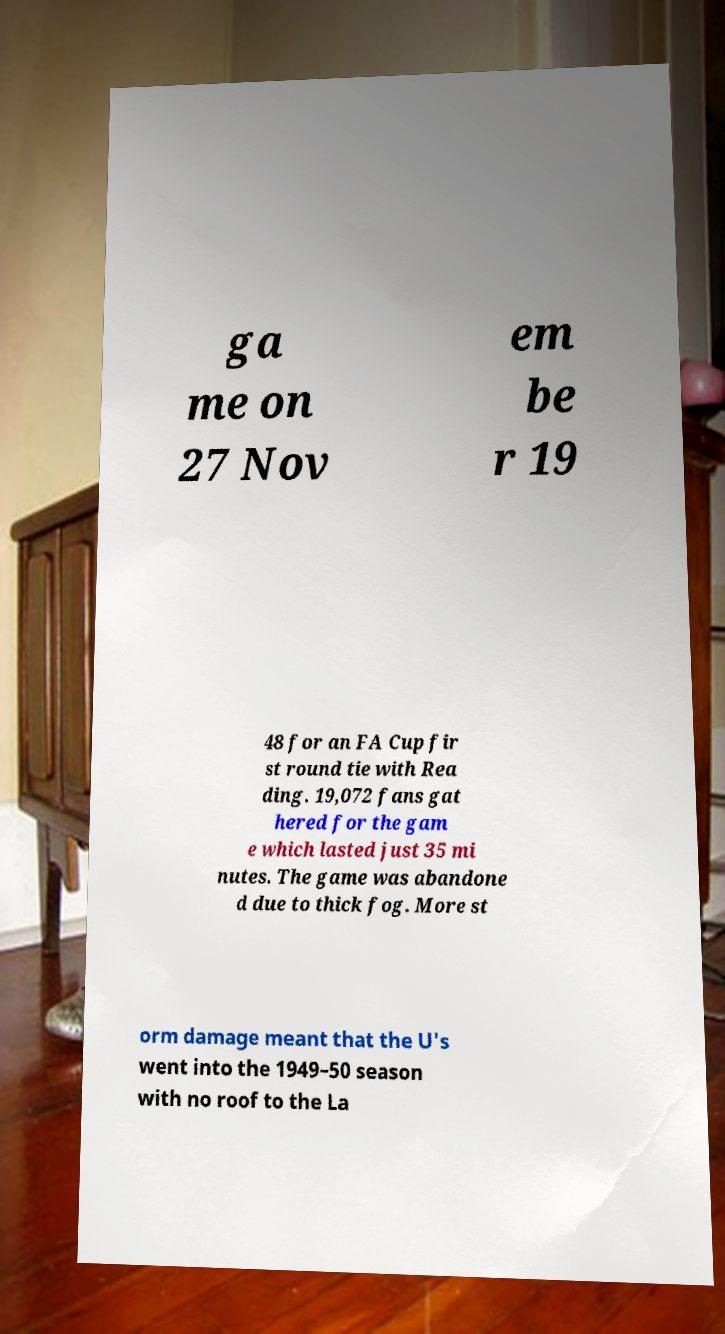Please identify and transcribe the text found in this image. ga me on 27 Nov em be r 19 48 for an FA Cup fir st round tie with Rea ding. 19,072 fans gat hered for the gam e which lasted just 35 mi nutes. The game was abandone d due to thick fog. More st orm damage meant that the U's went into the 1949–50 season with no roof to the La 